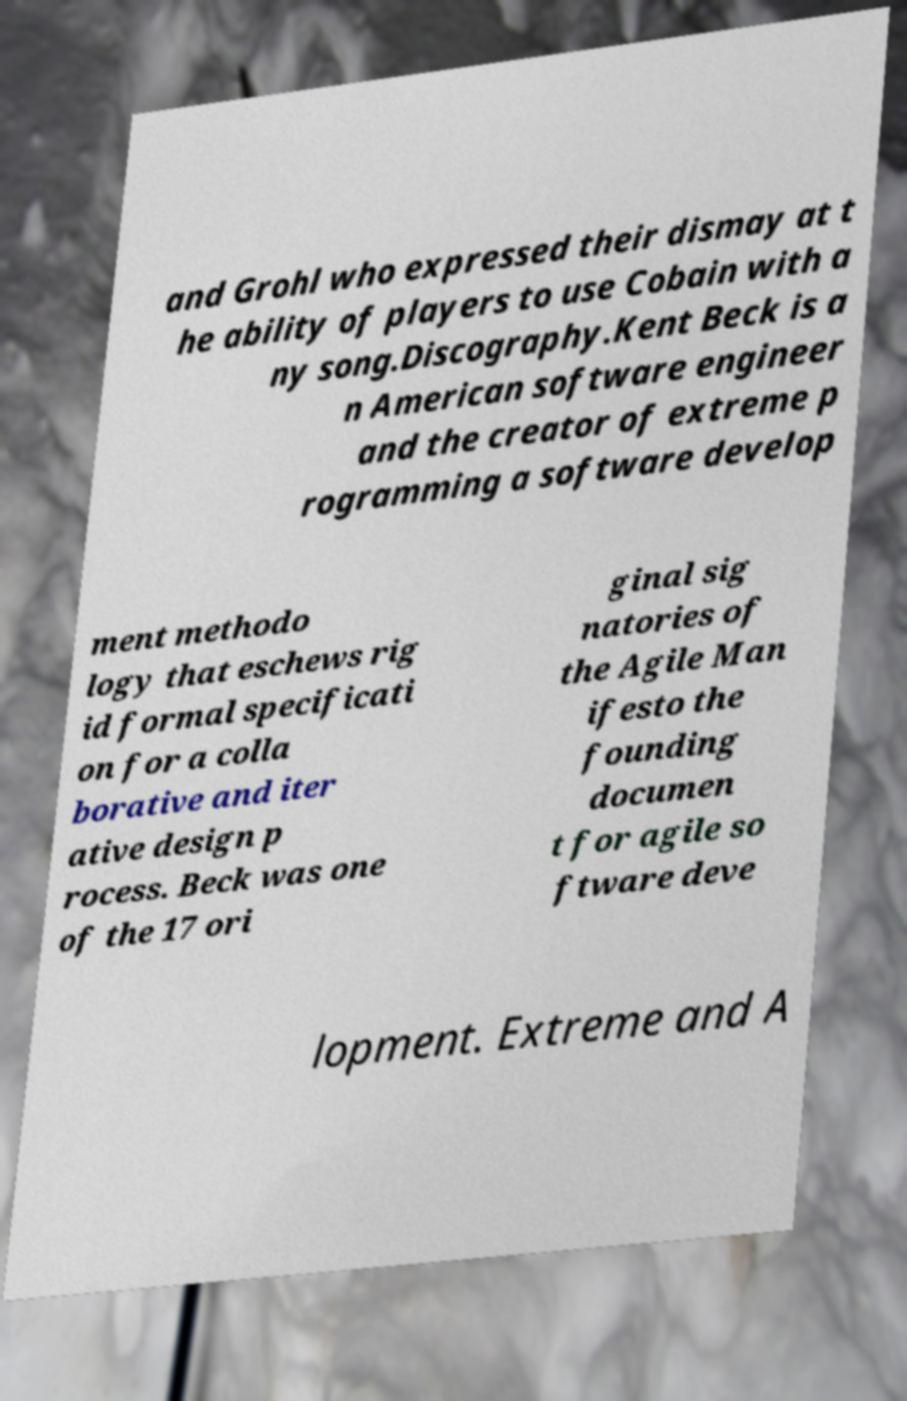Can you accurately transcribe the text from the provided image for me? and Grohl who expressed their dismay at t he ability of players to use Cobain with a ny song.Discography.Kent Beck is a n American software engineer and the creator of extreme p rogramming a software develop ment methodo logy that eschews rig id formal specificati on for a colla borative and iter ative design p rocess. Beck was one of the 17 ori ginal sig natories of the Agile Man ifesto the founding documen t for agile so ftware deve lopment. Extreme and A 